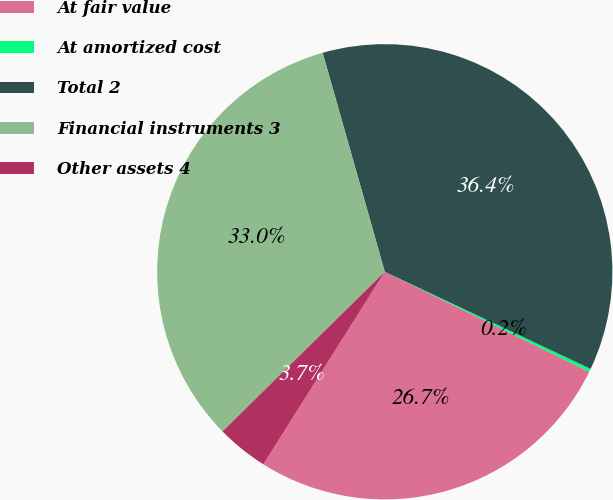Convert chart. <chart><loc_0><loc_0><loc_500><loc_500><pie_chart><fcel>At fair value<fcel>At amortized cost<fcel>Total 2<fcel>Financial instruments 3<fcel>Other assets 4<nl><fcel>26.72%<fcel>0.22%<fcel>36.41%<fcel>32.97%<fcel>3.67%<nl></chart> 